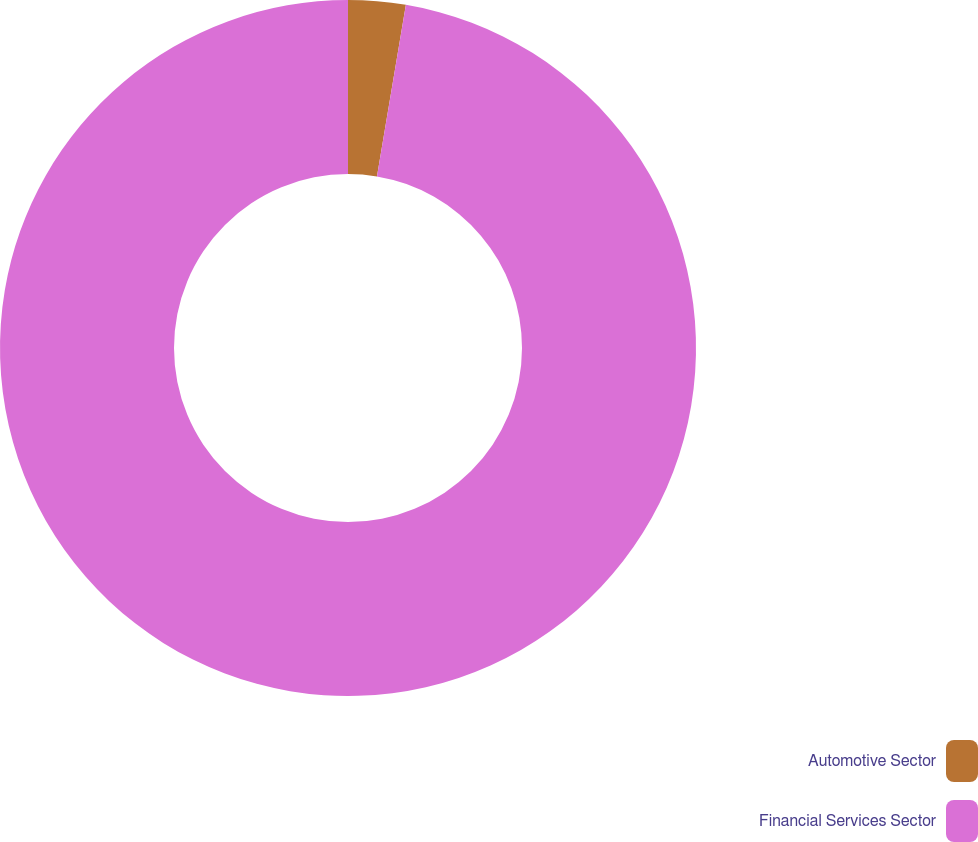<chart> <loc_0><loc_0><loc_500><loc_500><pie_chart><fcel>Automotive Sector<fcel>Financial Services Sector<nl><fcel>2.66%<fcel>97.34%<nl></chart> 